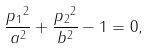<formula> <loc_0><loc_0><loc_500><loc_500>\frac { { p _ { 1 } } ^ { 2 } } { a ^ { 2 } } + \frac { { p _ { 2 } } ^ { 2 } } { b ^ { 2 } } - 1 = 0 ,</formula> 